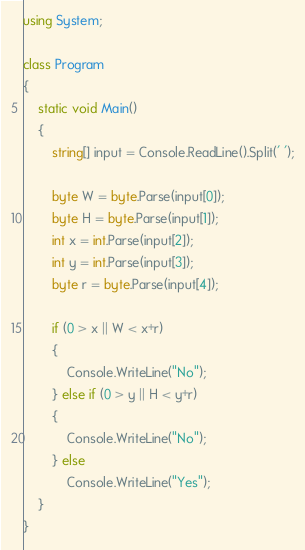Convert code to text. <code><loc_0><loc_0><loc_500><loc_500><_C#_>using System;

class Program
{
    static void Main()
    {
        string[] input = Console.ReadLine().Split(' ');

        byte W = byte.Parse(input[0]);
        byte H = byte.Parse(input[1]);
        int x = int.Parse(input[2]);
        int y = int.Parse(input[3]);
        byte r = byte.Parse(input[4]);

		if (0 > x || W < x+r)
		{
			Console.WriteLine("No");
		} else if (0 > y || H < y+r)
		{
			Console.WriteLine("No");
		} else
			Console.WriteLine("Yes");
    }
}
</code> 